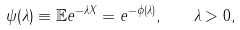<formula> <loc_0><loc_0><loc_500><loc_500>\psi ( \lambda ) \equiv \mathbb { E } e ^ { - \lambda X } = e ^ { - \phi ( \lambda ) } , \quad \lambda > 0 ,</formula> 